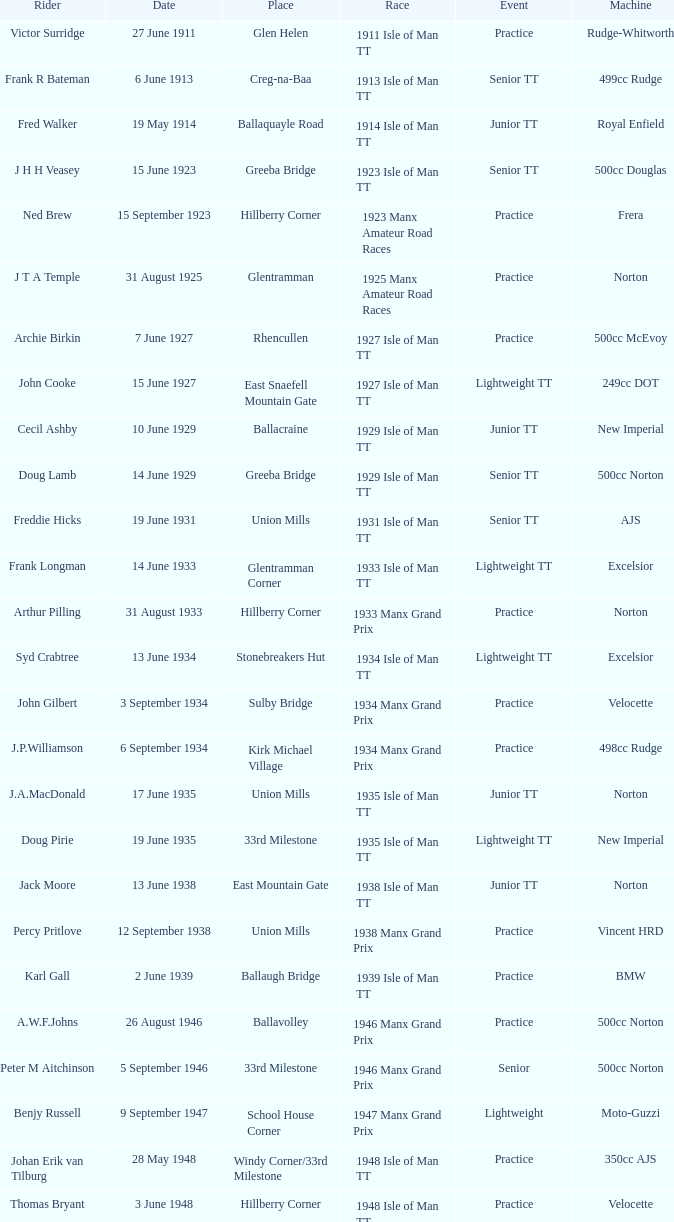Where was the yamaha with a 249cc engine located? Glentramman. 